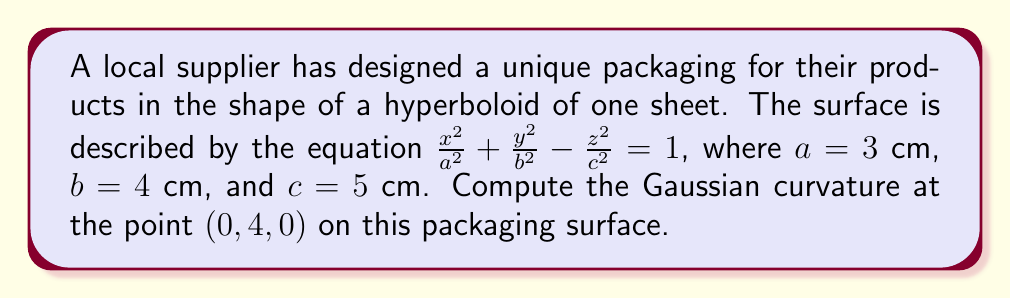Could you help me with this problem? To compute the Gaussian curvature, we'll follow these steps:

1) The Gaussian curvature K is given by $K = \frac{LN - M^2}{EG - F^2}$, where E, F, G are the coefficients of the first fundamental form, and L, M, N are the coefficients of the second fundamental form.

2) For a surface of the form $f(x,y,z) = 0$, we can use the formula:

   $$K = -\frac{\begin{vmatrix}
   f_{xx} & f_{xy} & f_{xz} \\
   f_{yx} & f_{yy} & f_{yz} \\
   f_{zx} & f_{zy} & f_{zz}
   \end{vmatrix}}
   {(f_x^2 + f_y^2 + f_z^2)^2}$$

3) Our surface is $f(x,y,z) = \frac{x^2}{9} + \frac{y^2}{16} - \frac{z^2}{25} - 1 = 0$

4) Calculate partial derivatives:
   $f_x = \frac{2x}{9}$, $f_y = \frac{y}{8}$, $f_z = -\frac{2z}{25}$
   $f_{xx} = \frac{2}{9}$, $f_{yy} = \frac{1}{8}$, $f_{zz} = -\frac{2}{25}$
   $f_{xy} = f_{yx} = f_{xz} = f_{zx} = f_{yz} = f_{zy} = 0$

5) At the point $(0, 4, 0)$:
   $f_x = 0$, $f_y = \frac{1}{2}$, $f_z = 0$

6) Substitute into the formula:

   $$K = -\frac{\begin{vmatrix}
   \frac{2}{9} & 0 & 0 \\
   0 & \frac{1}{8} & 0 \\
   0 & 0 & -\frac{2}{25}
   \end{vmatrix}}
   {(0^2 + (\frac{1}{2})^2 + 0^2)^2}$$

7) Evaluate the determinant:

   $$K = -\frac{\frac{2}{9} \cdot \frac{1}{8} \cdot (-\frac{2}{25})}{(\frac{1}{4})^2} = -\frac{-\frac{1}{450}}{\frac{1}{16}} = -\frac{16}{-450} = -\frac{4}{-450} = \frac{1}{112.5}$$

Therefore, the Gaussian curvature at the point $(0, 4, 0)$ is $\frac{1}{112.5}$ cm^(-2).
Answer: $\frac{1}{112.5}$ cm^(-2) 